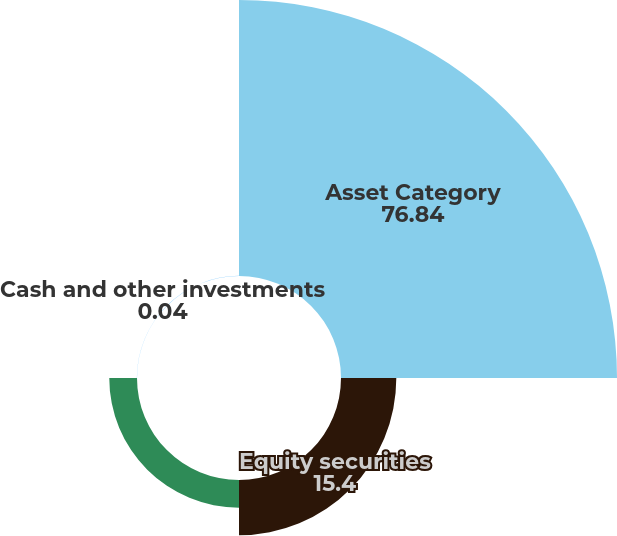<chart> <loc_0><loc_0><loc_500><loc_500><pie_chart><fcel>Asset Category<fcel>Equity securities<fcel>Fixed income securities<fcel>Cash and other investments<nl><fcel>76.84%<fcel>15.4%<fcel>7.72%<fcel>0.04%<nl></chart> 